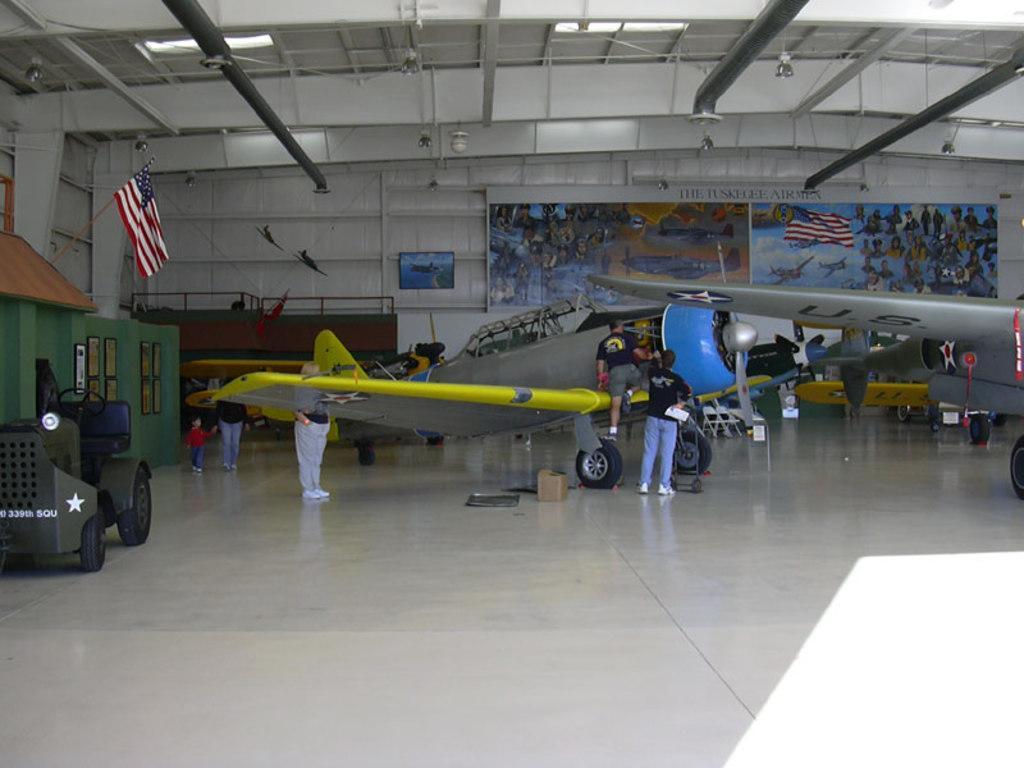Could you give a brief overview of what you see in this image? In this image we can see airplanes and people on the floor. In the background, we can see a banner and a monitor on the wall. At the top of the image, we can see the roof. On the left side of the image, we can see a vehicle, flag and frames are attached to the wall. 